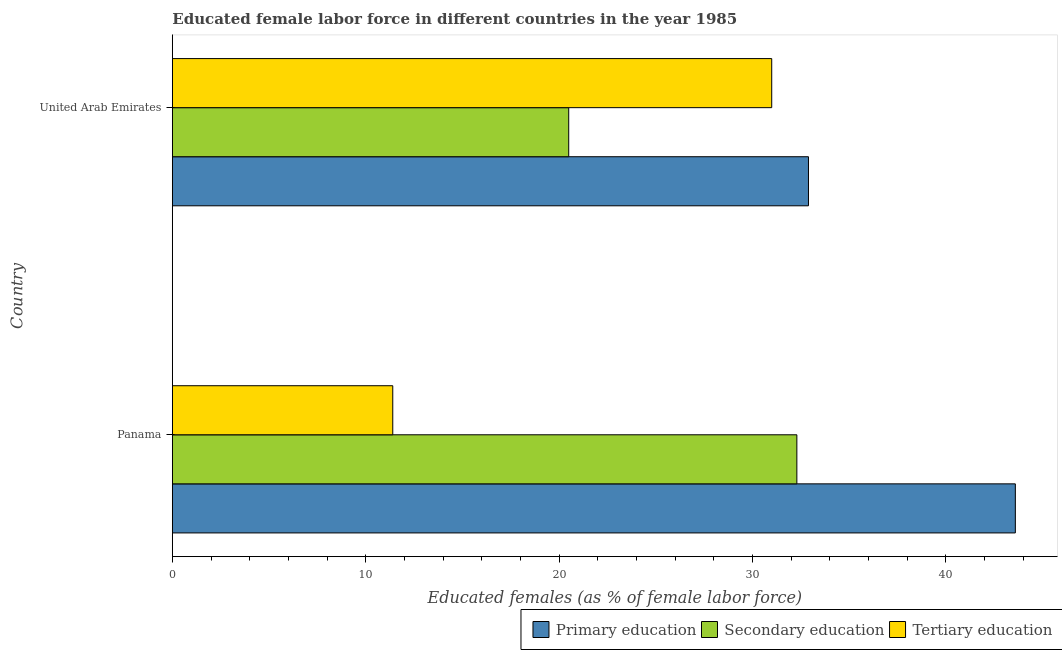Are the number of bars on each tick of the Y-axis equal?
Make the answer very short. Yes. How many bars are there on the 1st tick from the bottom?
Give a very brief answer. 3. What is the label of the 1st group of bars from the top?
Provide a short and direct response. United Arab Emirates. In how many cases, is the number of bars for a given country not equal to the number of legend labels?
Your answer should be compact. 0. Across all countries, what is the maximum percentage of female labor force who received tertiary education?
Your answer should be compact. 31. Across all countries, what is the minimum percentage of female labor force who received tertiary education?
Your answer should be compact. 11.4. In which country was the percentage of female labor force who received tertiary education maximum?
Provide a short and direct response. United Arab Emirates. In which country was the percentage of female labor force who received tertiary education minimum?
Ensure brevity in your answer.  Panama. What is the total percentage of female labor force who received secondary education in the graph?
Offer a terse response. 52.8. What is the difference between the percentage of female labor force who received secondary education in Panama and that in United Arab Emirates?
Your answer should be very brief. 11.8. What is the difference between the percentage of female labor force who received tertiary education in Panama and the percentage of female labor force who received primary education in United Arab Emirates?
Your answer should be very brief. -21.5. What is the average percentage of female labor force who received tertiary education per country?
Provide a short and direct response. 21.2. What is the ratio of the percentage of female labor force who received secondary education in Panama to that in United Arab Emirates?
Ensure brevity in your answer.  1.58. Is it the case that in every country, the sum of the percentage of female labor force who received primary education and percentage of female labor force who received secondary education is greater than the percentage of female labor force who received tertiary education?
Provide a succinct answer. Yes. Are all the bars in the graph horizontal?
Give a very brief answer. Yes. How many countries are there in the graph?
Your response must be concise. 2. Are the values on the major ticks of X-axis written in scientific E-notation?
Provide a succinct answer. No. Does the graph contain grids?
Your answer should be compact. No. Where does the legend appear in the graph?
Make the answer very short. Bottom right. How are the legend labels stacked?
Your answer should be very brief. Horizontal. What is the title of the graph?
Your answer should be compact. Educated female labor force in different countries in the year 1985. Does "Food" appear as one of the legend labels in the graph?
Your answer should be compact. No. What is the label or title of the X-axis?
Your response must be concise. Educated females (as % of female labor force). What is the Educated females (as % of female labor force) in Primary education in Panama?
Your response must be concise. 43.6. What is the Educated females (as % of female labor force) in Secondary education in Panama?
Offer a very short reply. 32.3. What is the Educated females (as % of female labor force) of Tertiary education in Panama?
Ensure brevity in your answer.  11.4. What is the Educated females (as % of female labor force) of Primary education in United Arab Emirates?
Your answer should be compact. 32.9. Across all countries, what is the maximum Educated females (as % of female labor force) of Primary education?
Your answer should be very brief. 43.6. Across all countries, what is the maximum Educated females (as % of female labor force) in Secondary education?
Provide a succinct answer. 32.3. Across all countries, what is the maximum Educated females (as % of female labor force) of Tertiary education?
Ensure brevity in your answer.  31. Across all countries, what is the minimum Educated females (as % of female labor force) in Primary education?
Provide a short and direct response. 32.9. Across all countries, what is the minimum Educated females (as % of female labor force) in Tertiary education?
Give a very brief answer. 11.4. What is the total Educated females (as % of female labor force) of Primary education in the graph?
Keep it short and to the point. 76.5. What is the total Educated females (as % of female labor force) of Secondary education in the graph?
Your answer should be very brief. 52.8. What is the total Educated females (as % of female labor force) in Tertiary education in the graph?
Your answer should be very brief. 42.4. What is the difference between the Educated females (as % of female labor force) in Primary education in Panama and that in United Arab Emirates?
Provide a succinct answer. 10.7. What is the difference between the Educated females (as % of female labor force) in Tertiary education in Panama and that in United Arab Emirates?
Make the answer very short. -19.6. What is the difference between the Educated females (as % of female labor force) of Primary education in Panama and the Educated females (as % of female labor force) of Secondary education in United Arab Emirates?
Give a very brief answer. 23.1. What is the difference between the Educated females (as % of female labor force) of Secondary education in Panama and the Educated females (as % of female labor force) of Tertiary education in United Arab Emirates?
Make the answer very short. 1.3. What is the average Educated females (as % of female labor force) of Primary education per country?
Give a very brief answer. 38.25. What is the average Educated females (as % of female labor force) of Secondary education per country?
Make the answer very short. 26.4. What is the average Educated females (as % of female labor force) of Tertiary education per country?
Your response must be concise. 21.2. What is the difference between the Educated females (as % of female labor force) in Primary education and Educated females (as % of female labor force) in Tertiary education in Panama?
Ensure brevity in your answer.  32.2. What is the difference between the Educated females (as % of female labor force) in Secondary education and Educated females (as % of female labor force) in Tertiary education in Panama?
Your answer should be compact. 20.9. What is the difference between the Educated females (as % of female labor force) of Primary education and Educated females (as % of female labor force) of Secondary education in United Arab Emirates?
Your answer should be very brief. 12.4. What is the ratio of the Educated females (as % of female labor force) in Primary education in Panama to that in United Arab Emirates?
Offer a very short reply. 1.33. What is the ratio of the Educated females (as % of female labor force) in Secondary education in Panama to that in United Arab Emirates?
Your answer should be very brief. 1.58. What is the ratio of the Educated females (as % of female labor force) of Tertiary education in Panama to that in United Arab Emirates?
Your answer should be very brief. 0.37. What is the difference between the highest and the second highest Educated females (as % of female labor force) of Tertiary education?
Offer a terse response. 19.6. What is the difference between the highest and the lowest Educated females (as % of female labor force) in Primary education?
Provide a short and direct response. 10.7. What is the difference between the highest and the lowest Educated females (as % of female labor force) of Tertiary education?
Offer a terse response. 19.6. 